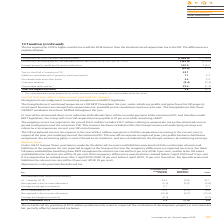According to Intu Properties's financial document, Why did the net deferred tax provision of £0.9 million arise? in respect of the revaluation of development property at intu Costa del Sol, partially offset by associated tax losses. The document states: "ax provision of £0.9 million predominantly arises in respect of the revaluation of development property at intu Costa del Sol, partially offset by ass..." Also, What is the relevant tax rate for those UK assets and liabilities benefiting from REIT exemption in 2019? According to the financial document, 0 per cent. The relevant text states: "from REIT exemption the relevant tax rate will be 0 per cent (2018: 0 per cent), and for other UK assets and liabilities the relevant rate will be 19 per cent i from REIT exemption the relevant tax ra..." Also, What is the relevant tax rate for Spanish assets and liabilities? According to the financial document, 25 per cent. The relevant text states: "ets and liabilities the relevant tax rate will be 25 per cent (2018: 25 per cent). ets and liabilities the relevant tax rate will be 25 per cent (2018: 25 per cent)...." Also, can you calculate: What is the percentage change in the provided deferred tax provision for investment and development property from 1 January 2018 to 31 December 2019? To answer this question, I need to perform calculations using the financial data. The calculation is: (2.3-24.6)/24.6, which equals -90.65 (percentage). This is based on the information: "At 1 January 2018 24.6 (0.9) 23.7 At 31 December 2019 2.3 (1.4) 0.9..." The key data points involved are: 2.3, 24.6. Also, can you calculate: What is the percentage change in the total provided deferred tax provision from 1 January 2018 to 31 December 2019? To answer this question, I need to perform calculations using the financial data. The calculation is: (0.9-23.7)/0.9, which equals -2533.33 (percentage). This is based on the information: "At 1 January 2018 24.6 (0.9) 23.7 At 1 January 2018 24.6 (0.9) 23.7..." The key data points involved are: 0.9, 23.7. Also, can you calculate: What is the percentage change in the provided deferred tax provision for investment and development property from 31 December 2018 to 31 December 2019? To answer this question, I need to perform calculations using the financial data. The calculation is: (2.3-19.2)/19.2, which equals -88.02 (percentage). This is based on the information: "At 31 December 2018 19.2 (1.2) 18.0 At 31 December 2019 2.3 (1.4) 0.9..." The key data points involved are: 19.2, 2.3. 